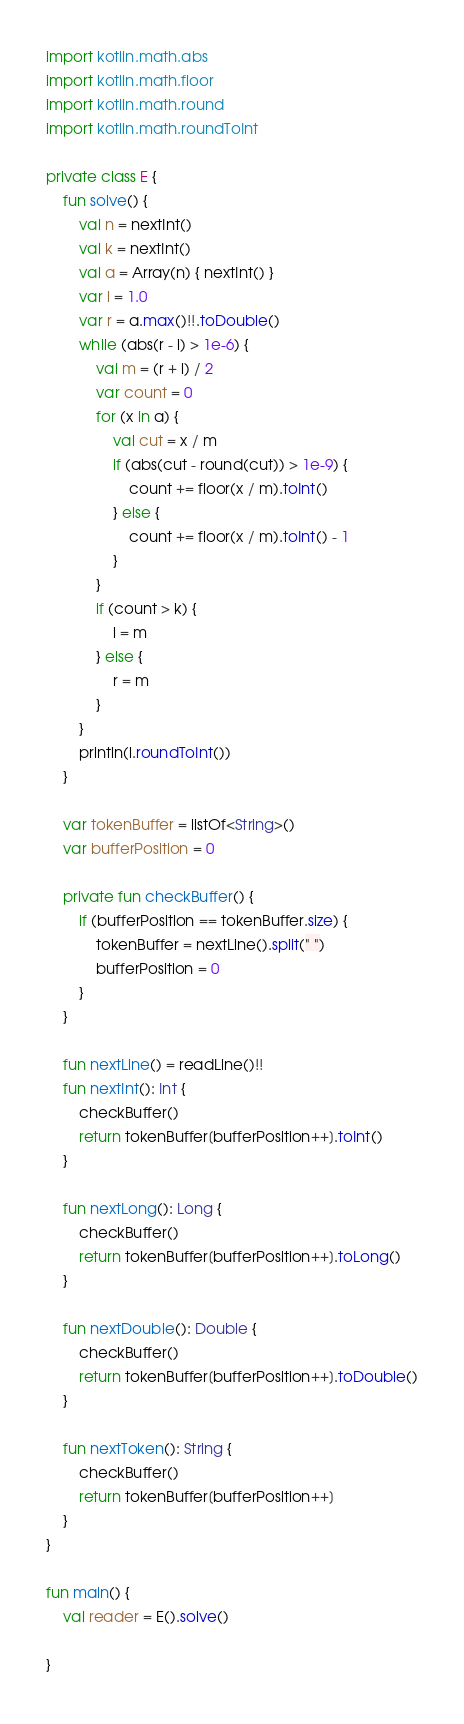<code> <loc_0><loc_0><loc_500><loc_500><_Kotlin_>import kotlin.math.abs
import kotlin.math.floor
import kotlin.math.round
import kotlin.math.roundToInt

private class E {
    fun solve() {
        val n = nextInt()
        val k = nextInt()
        val a = Array(n) { nextInt() }
        var l = 1.0
        var r = a.max()!!.toDouble()
        while (abs(r - l) > 1e-6) {
            val m = (r + l) / 2
            var count = 0
            for (x in a) {
                val cut = x / m
                if (abs(cut - round(cut)) > 1e-9) {
                    count += floor(x / m).toInt()
                } else {
                    count += floor(x / m).toInt() - 1
                }
            }
            if (count > k) {
                l = m
            } else {
                r = m
            }
        }
        println(l.roundToInt())
    }

    var tokenBuffer = listOf<String>()
    var bufferPosition = 0

    private fun checkBuffer() {
        if (bufferPosition == tokenBuffer.size) {
            tokenBuffer = nextLine().split(" ")
            bufferPosition = 0
        }
    }

    fun nextLine() = readLine()!!
    fun nextInt(): Int {
        checkBuffer()
        return tokenBuffer[bufferPosition++].toInt()
    }

    fun nextLong(): Long {
        checkBuffer()
        return tokenBuffer[bufferPosition++].toLong()
    }

    fun nextDouble(): Double {
        checkBuffer()
        return tokenBuffer[bufferPosition++].toDouble()
    }

    fun nextToken(): String {
        checkBuffer()
        return tokenBuffer[bufferPosition++]
    }
}

fun main() {
    val reader = E().solve()

}
</code> 